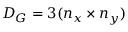Convert formula to latex. <formula><loc_0><loc_0><loc_500><loc_500>D _ { G } = 3 ( n _ { x } \times n _ { y } )</formula> 